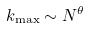<formula> <loc_0><loc_0><loc_500><loc_500>k _ { \max } \sim N ^ { \theta }</formula> 